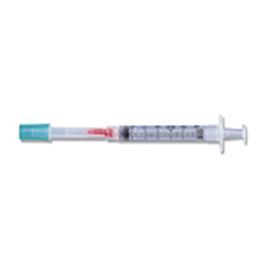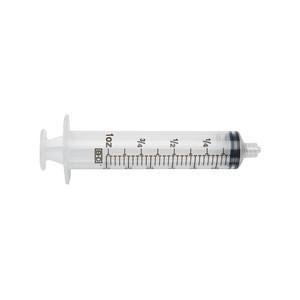The first image is the image on the left, the second image is the image on the right. Given the left and right images, does the statement "Both syringes are exactly horizontal." hold true? Answer yes or no. Yes. The first image is the image on the left, the second image is the image on the right. Given the left and right images, does the statement "The left and right image contains the same number syringes facing opposite directions." hold true? Answer yes or no. Yes. 